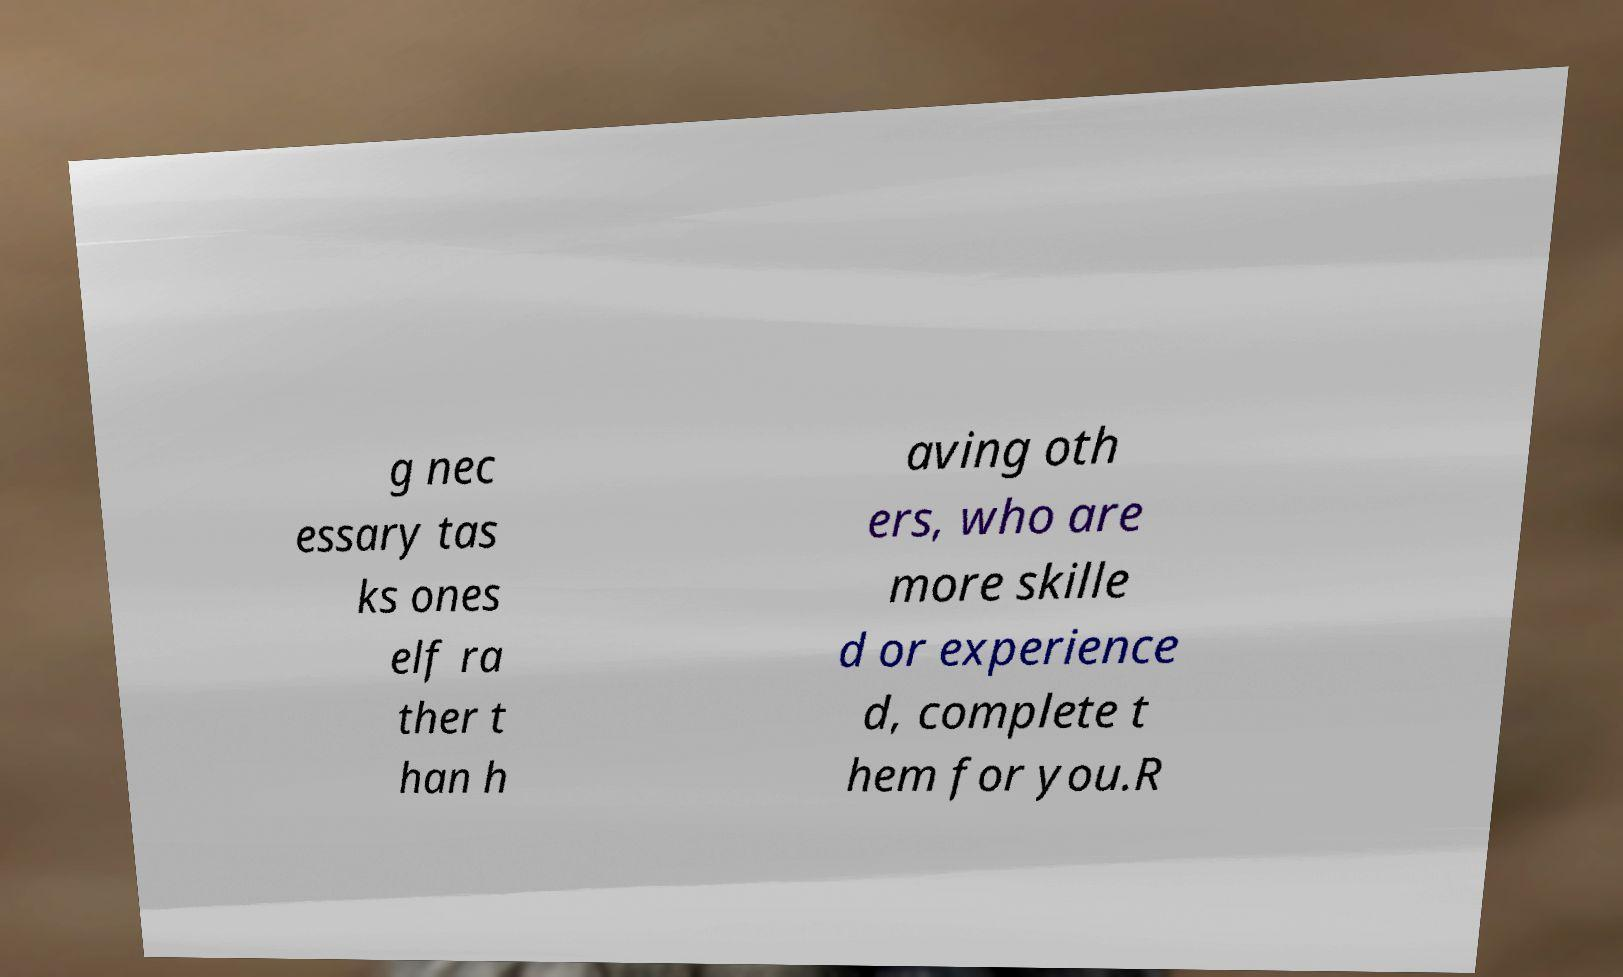Can you accurately transcribe the text from the provided image for me? g nec essary tas ks ones elf ra ther t han h aving oth ers, who are more skille d or experience d, complete t hem for you.R 